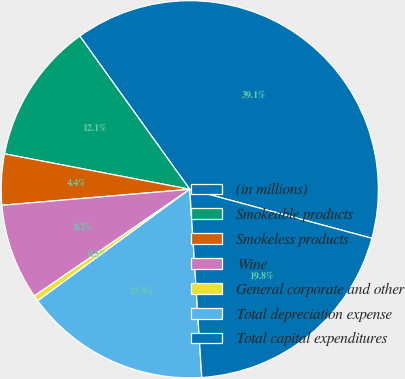<chart> <loc_0><loc_0><loc_500><loc_500><pie_chart><fcel>(in millions)<fcel>Smokeable products<fcel>Smokeless products<fcel>Wine<fcel>General corporate and other<fcel>Total depreciation expense<fcel>Total capital expenditures<nl><fcel>39.09%<fcel>12.08%<fcel>4.36%<fcel>8.22%<fcel>0.5%<fcel>15.94%<fcel>19.8%<nl></chart> 